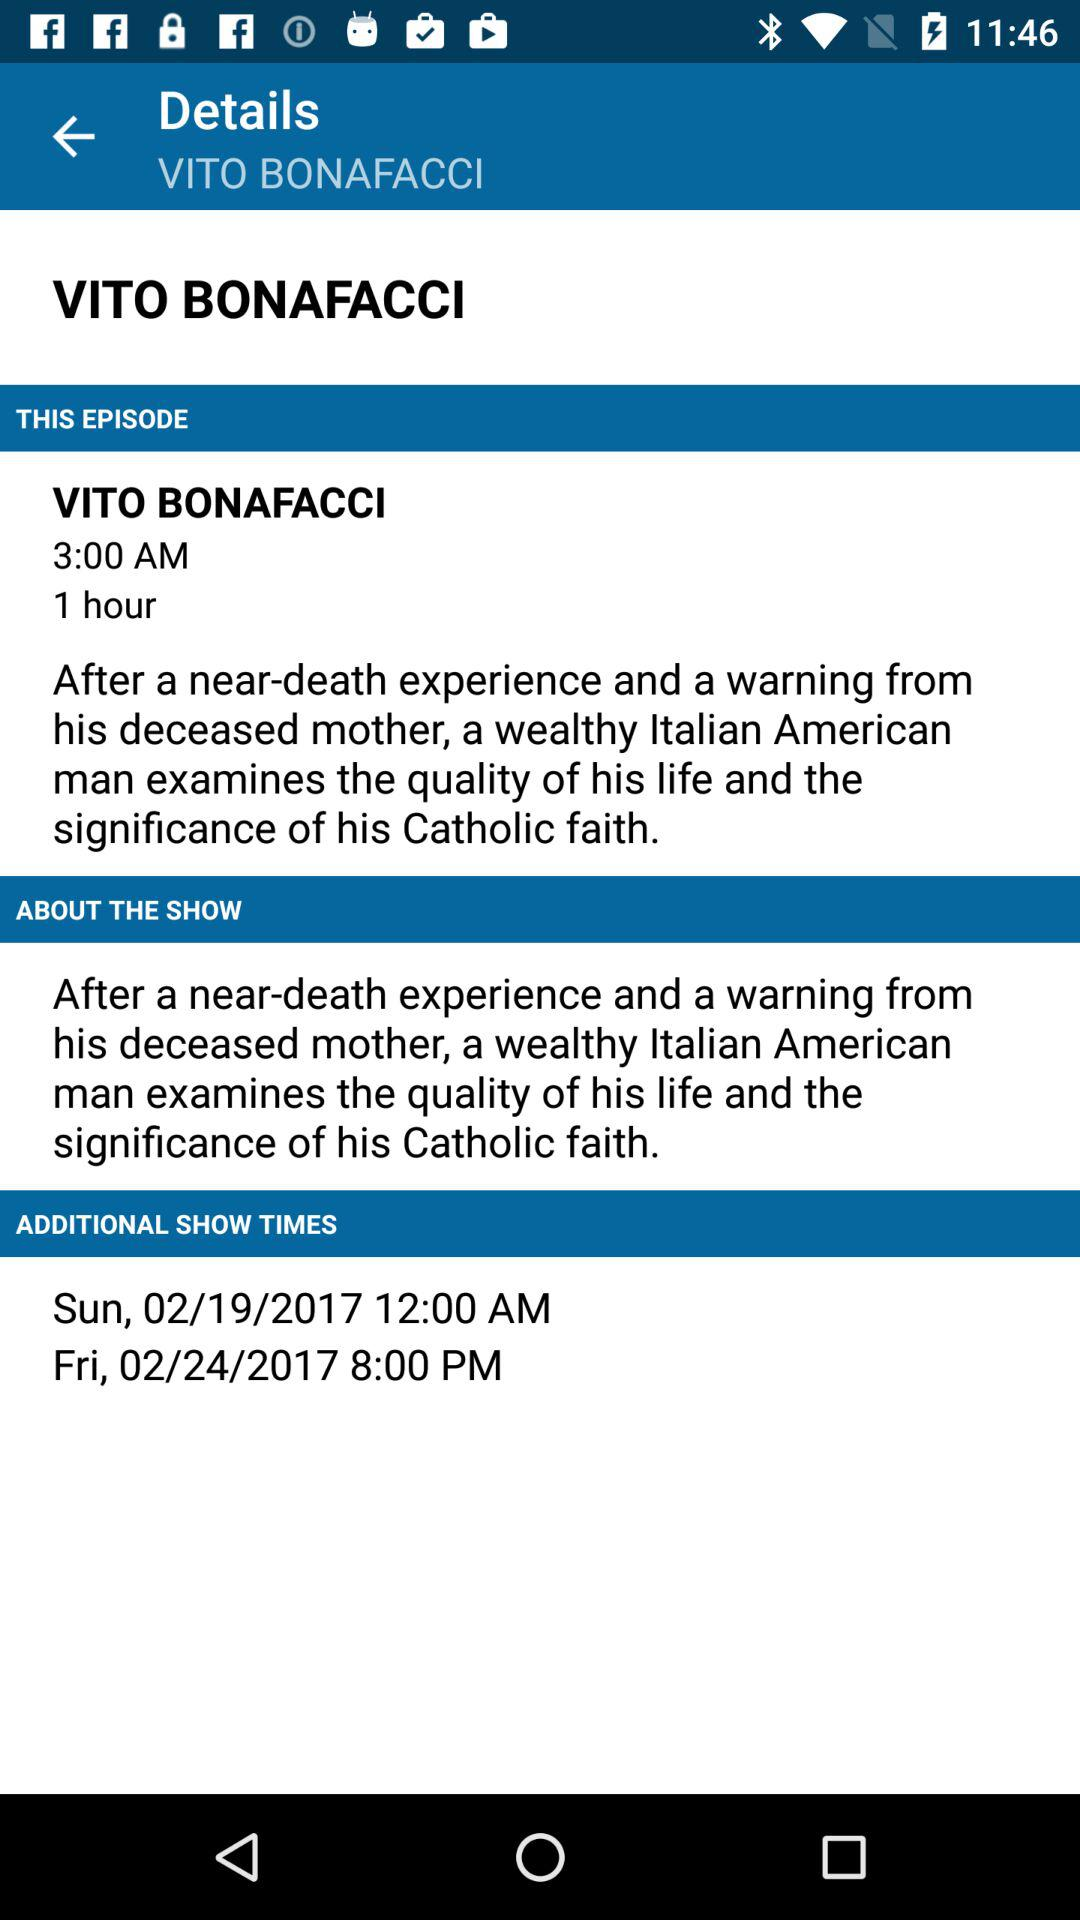What is the movie name? The movie name is "VITO BONAFACCI". 